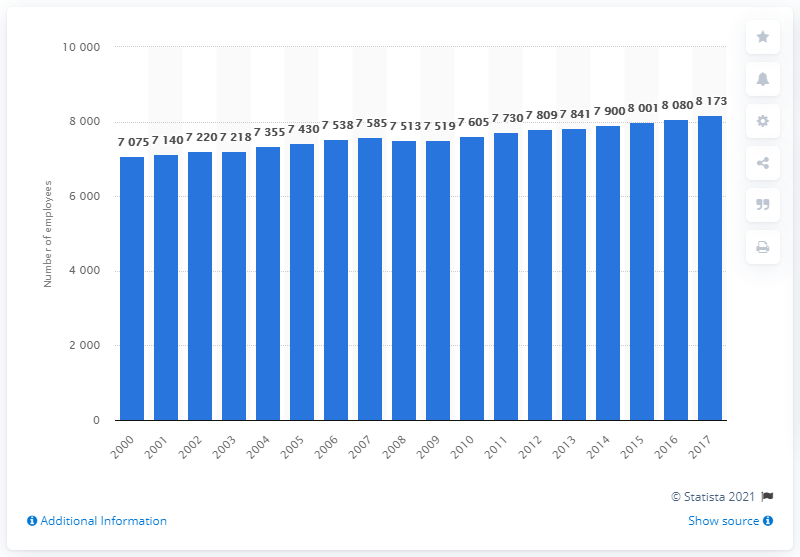Give some essential details in this illustration. In 2017, there were 8,173 dentists employed in Sweden. 